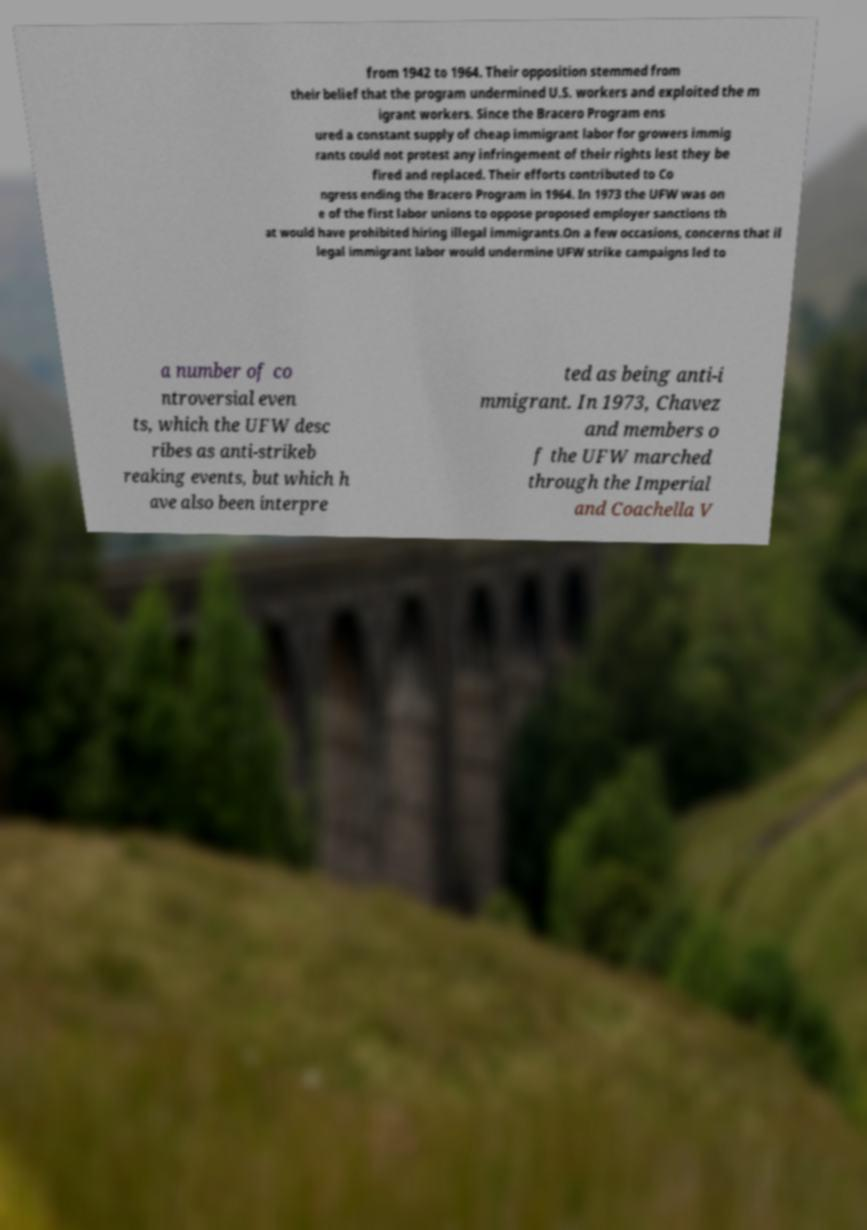What messages or text are displayed in this image? I need them in a readable, typed format. from 1942 to 1964. Their opposition stemmed from their belief that the program undermined U.S. workers and exploited the m igrant workers. Since the Bracero Program ens ured a constant supply of cheap immigrant labor for growers immig rants could not protest any infringement of their rights lest they be fired and replaced. Their efforts contributed to Co ngress ending the Bracero Program in 1964. In 1973 the UFW was on e of the first labor unions to oppose proposed employer sanctions th at would have prohibited hiring illegal immigrants.On a few occasions, concerns that il legal immigrant labor would undermine UFW strike campaigns led to a number of co ntroversial even ts, which the UFW desc ribes as anti-strikeb reaking events, but which h ave also been interpre ted as being anti-i mmigrant. In 1973, Chavez and members o f the UFW marched through the Imperial and Coachella V 